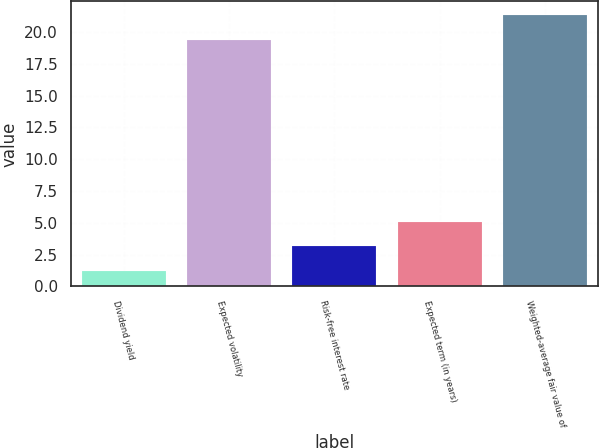<chart> <loc_0><loc_0><loc_500><loc_500><bar_chart><fcel>Dividend yield<fcel>Expected volatility<fcel>Risk-free interest rate<fcel>Expected term (in years)<fcel>Weighted-average fair value of<nl><fcel>1.2<fcel>19.4<fcel>3.14<fcel>5.08<fcel>21.34<nl></chart> 